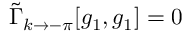<formula> <loc_0><loc_0><loc_500><loc_500>\tilde { \Gamma } _ { k \to - \pi } [ g _ { 1 } , g _ { 1 } ] = 0</formula> 